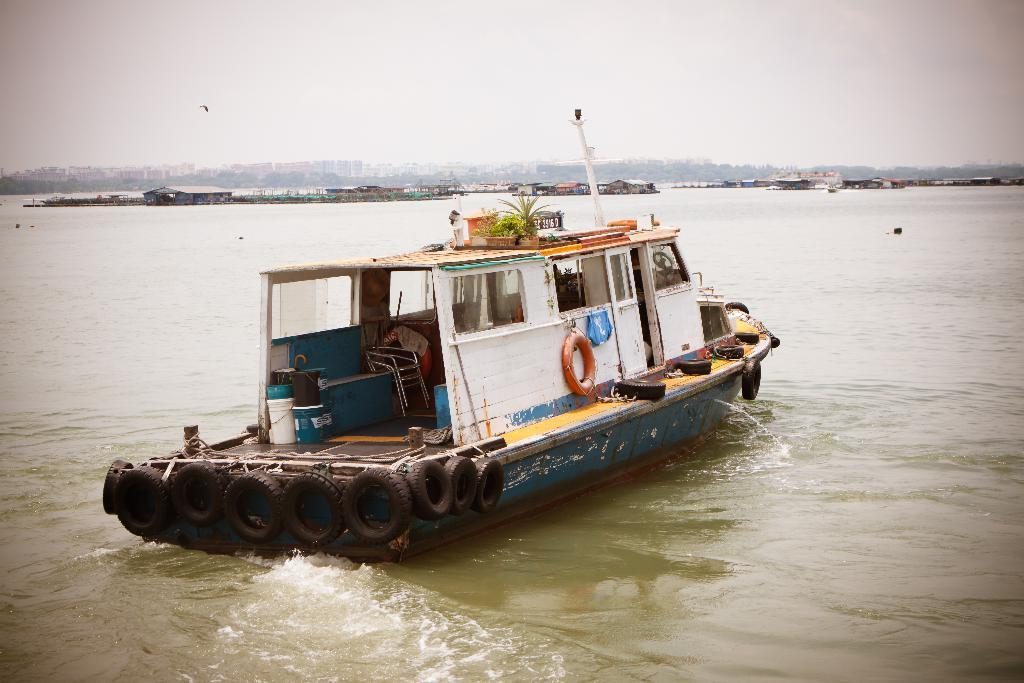What is the main subject in the foreground of the image? There is a boat in the foreground of the image. What is the boat's location in relation to the water? The boat is on the water. What can be seen in the background of the image? There are huts, buildings, trees, and the sky visible in the background of the image. What type of camera can be seen hanging from the boat in the image? There is no camera visible in the image; the focus is on the boat and its surroundings. 